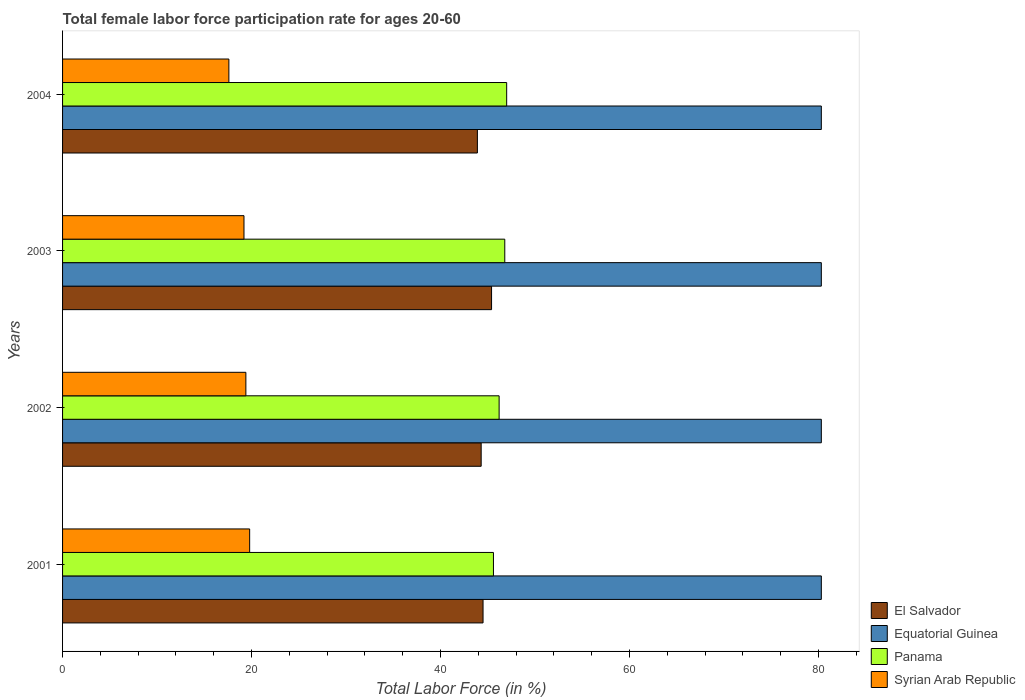How many different coloured bars are there?
Ensure brevity in your answer.  4. How many groups of bars are there?
Ensure brevity in your answer.  4. How many bars are there on the 1st tick from the top?
Ensure brevity in your answer.  4. In how many cases, is the number of bars for a given year not equal to the number of legend labels?
Make the answer very short. 0. What is the female labor force participation rate in Syrian Arab Republic in 2001?
Your answer should be very brief. 19.8. Across all years, what is the maximum female labor force participation rate in Syrian Arab Republic?
Your answer should be compact. 19.8. Across all years, what is the minimum female labor force participation rate in Panama?
Ensure brevity in your answer.  45.6. What is the total female labor force participation rate in Panama in the graph?
Your answer should be compact. 185.6. What is the difference between the female labor force participation rate in Syrian Arab Republic in 2004 and the female labor force participation rate in Equatorial Guinea in 2001?
Your answer should be very brief. -62.7. In the year 2001, what is the difference between the female labor force participation rate in El Salvador and female labor force participation rate in Panama?
Ensure brevity in your answer.  -1.1. In how many years, is the female labor force participation rate in Syrian Arab Republic greater than 20 %?
Provide a short and direct response. 0. What is the ratio of the female labor force participation rate in Equatorial Guinea in 2001 to that in 2004?
Keep it short and to the point. 1. What is the difference between the highest and the second highest female labor force participation rate in El Salvador?
Provide a short and direct response. 0.9. What is the difference between the highest and the lowest female labor force participation rate in Syrian Arab Republic?
Make the answer very short. 2.2. What does the 2nd bar from the top in 2002 represents?
Your answer should be very brief. Panama. What does the 1st bar from the bottom in 2004 represents?
Your response must be concise. El Salvador. Is it the case that in every year, the sum of the female labor force participation rate in El Salvador and female labor force participation rate in Panama is greater than the female labor force participation rate in Syrian Arab Republic?
Make the answer very short. Yes. How many bars are there?
Offer a terse response. 16. Are the values on the major ticks of X-axis written in scientific E-notation?
Offer a terse response. No. Does the graph contain any zero values?
Provide a short and direct response. No. Where does the legend appear in the graph?
Ensure brevity in your answer.  Bottom right. How many legend labels are there?
Your answer should be compact. 4. How are the legend labels stacked?
Provide a succinct answer. Vertical. What is the title of the graph?
Provide a short and direct response. Total female labor force participation rate for ages 20-60. Does "Guinea" appear as one of the legend labels in the graph?
Your answer should be compact. No. What is the Total Labor Force (in %) of El Salvador in 2001?
Your response must be concise. 44.5. What is the Total Labor Force (in %) of Equatorial Guinea in 2001?
Your answer should be compact. 80.3. What is the Total Labor Force (in %) of Panama in 2001?
Provide a succinct answer. 45.6. What is the Total Labor Force (in %) in Syrian Arab Republic in 2001?
Offer a very short reply. 19.8. What is the Total Labor Force (in %) in El Salvador in 2002?
Your answer should be compact. 44.3. What is the Total Labor Force (in %) of Equatorial Guinea in 2002?
Give a very brief answer. 80.3. What is the Total Labor Force (in %) of Panama in 2002?
Give a very brief answer. 46.2. What is the Total Labor Force (in %) in Syrian Arab Republic in 2002?
Your answer should be compact. 19.4. What is the Total Labor Force (in %) in El Salvador in 2003?
Offer a very short reply. 45.4. What is the Total Labor Force (in %) in Equatorial Guinea in 2003?
Offer a very short reply. 80.3. What is the Total Labor Force (in %) of Panama in 2003?
Your answer should be very brief. 46.8. What is the Total Labor Force (in %) of Syrian Arab Republic in 2003?
Give a very brief answer. 19.2. What is the Total Labor Force (in %) in El Salvador in 2004?
Your response must be concise. 43.9. What is the Total Labor Force (in %) in Equatorial Guinea in 2004?
Your answer should be very brief. 80.3. What is the Total Labor Force (in %) in Syrian Arab Republic in 2004?
Give a very brief answer. 17.6. Across all years, what is the maximum Total Labor Force (in %) of El Salvador?
Make the answer very short. 45.4. Across all years, what is the maximum Total Labor Force (in %) in Equatorial Guinea?
Provide a succinct answer. 80.3. Across all years, what is the maximum Total Labor Force (in %) in Panama?
Offer a very short reply. 47. Across all years, what is the maximum Total Labor Force (in %) in Syrian Arab Republic?
Provide a succinct answer. 19.8. Across all years, what is the minimum Total Labor Force (in %) of El Salvador?
Ensure brevity in your answer.  43.9. Across all years, what is the minimum Total Labor Force (in %) in Equatorial Guinea?
Offer a very short reply. 80.3. Across all years, what is the minimum Total Labor Force (in %) of Panama?
Ensure brevity in your answer.  45.6. Across all years, what is the minimum Total Labor Force (in %) in Syrian Arab Republic?
Give a very brief answer. 17.6. What is the total Total Labor Force (in %) in El Salvador in the graph?
Provide a short and direct response. 178.1. What is the total Total Labor Force (in %) of Equatorial Guinea in the graph?
Your response must be concise. 321.2. What is the total Total Labor Force (in %) of Panama in the graph?
Give a very brief answer. 185.6. What is the total Total Labor Force (in %) in Syrian Arab Republic in the graph?
Keep it short and to the point. 76. What is the difference between the Total Labor Force (in %) in Equatorial Guinea in 2001 and that in 2002?
Your answer should be very brief. 0. What is the difference between the Total Labor Force (in %) in Syrian Arab Republic in 2001 and that in 2003?
Provide a succinct answer. 0.6. What is the difference between the Total Labor Force (in %) of Syrian Arab Republic in 2001 and that in 2004?
Your response must be concise. 2.2. What is the difference between the Total Labor Force (in %) of Panama in 2002 and that in 2004?
Your answer should be compact. -0.8. What is the difference between the Total Labor Force (in %) in El Salvador in 2003 and that in 2004?
Keep it short and to the point. 1.5. What is the difference between the Total Labor Force (in %) in Equatorial Guinea in 2003 and that in 2004?
Your response must be concise. 0. What is the difference between the Total Labor Force (in %) in Panama in 2003 and that in 2004?
Offer a terse response. -0.2. What is the difference between the Total Labor Force (in %) in El Salvador in 2001 and the Total Labor Force (in %) in Equatorial Guinea in 2002?
Keep it short and to the point. -35.8. What is the difference between the Total Labor Force (in %) of El Salvador in 2001 and the Total Labor Force (in %) of Panama in 2002?
Offer a terse response. -1.7. What is the difference between the Total Labor Force (in %) in El Salvador in 2001 and the Total Labor Force (in %) in Syrian Arab Republic in 2002?
Keep it short and to the point. 25.1. What is the difference between the Total Labor Force (in %) in Equatorial Guinea in 2001 and the Total Labor Force (in %) in Panama in 2002?
Ensure brevity in your answer.  34.1. What is the difference between the Total Labor Force (in %) of Equatorial Guinea in 2001 and the Total Labor Force (in %) of Syrian Arab Republic in 2002?
Offer a terse response. 60.9. What is the difference between the Total Labor Force (in %) in Panama in 2001 and the Total Labor Force (in %) in Syrian Arab Republic in 2002?
Keep it short and to the point. 26.2. What is the difference between the Total Labor Force (in %) of El Salvador in 2001 and the Total Labor Force (in %) of Equatorial Guinea in 2003?
Offer a terse response. -35.8. What is the difference between the Total Labor Force (in %) of El Salvador in 2001 and the Total Labor Force (in %) of Syrian Arab Republic in 2003?
Ensure brevity in your answer.  25.3. What is the difference between the Total Labor Force (in %) in Equatorial Guinea in 2001 and the Total Labor Force (in %) in Panama in 2003?
Make the answer very short. 33.5. What is the difference between the Total Labor Force (in %) of Equatorial Guinea in 2001 and the Total Labor Force (in %) of Syrian Arab Republic in 2003?
Give a very brief answer. 61.1. What is the difference between the Total Labor Force (in %) in Panama in 2001 and the Total Labor Force (in %) in Syrian Arab Republic in 2003?
Provide a succinct answer. 26.4. What is the difference between the Total Labor Force (in %) in El Salvador in 2001 and the Total Labor Force (in %) in Equatorial Guinea in 2004?
Offer a very short reply. -35.8. What is the difference between the Total Labor Force (in %) in El Salvador in 2001 and the Total Labor Force (in %) in Syrian Arab Republic in 2004?
Ensure brevity in your answer.  26.9. What is the difference between the Total Labor Force (in %) in Equatorial Guinea in 2001 and the Total Labor Force (in %) in Panama in 2004?
Keep it short and to the point. 33.3. What is the difference between the Total Labor Force (in %) of Equatorial Guinea in 2001 and the Total Labor Force (in %) of Syrian Arab Republic in 2004?
Keep it short and to the point. 62.7. What is the difference between the Total Labor Force (in %) in El Salvador in 2002 and the Total Labor Force (in %) in Equatorial Guinea in 2003?
Give a very brief answer. -36. What is the difference between the Total Labor Force (in %) of El Salvador in 2002 and the Total Labor Force (in %) of Panama in 2003?
Offer a terse response. -2.5. What is the difference between the Total Labor Force (in %) of El Salvador in 2002 and the Total Labor Force (in %) of Syrian Arab Republic in 2003?
Your answer should be compact. 25.1. What is the difference between the Total Labor Force (in %) of Equatorial Guinea in 2002 and the Total Labor Force (in %) of Panama in 2003?
Your answer should be compact. 33.5. What is the difference between the Total Labor Force (in %) in Equatorial Guinea in 2002 and the Total Labor Force (in %) in Syrian Arab Republic in 2003?
Offer a very short reply. 61.1. What is the difference between the Total Labor Force (in %) of Panama in 2002 and the Total Labor Force (in %) of Syrian Arab Republic in 2003?
Provide a succinct answer. 27. What is the difference between the Total Labor Force (in %) of El Salvador in 2002 and the Total Labor Force (in %) of Equatorial Guinea in 2004?
Provide a short and direct response. -36. What is the difference between the Total Labor Force (in %) in El Salvador in 2002 and the Total Labor Force (in %) in Panama in 2004?
Offer a very short reply. -2.7. What is the difference between the Total Labor Force (in %) in El Salvador in 2002 and the Total Labor Force (in %) in Syrian Arab Republic in 2004?
Give a very brief answer. 26.7. What is the difference between the Total Labor Force (in %) of Equatorial Guinea in 2002 and the Total Labor Force (in %) of Panama in 2004?
Provide a succinct answer. 33.3. What is the difference between the Total Labor Force (in %) of Equatorial Guinea in 2002 and the Total Labor Force (in %) of Syrian Arab Republic in 2004?
Provide a short and direct response. 62.7. What is the difference between the Total Labor Force (in %) in Panama in 2002 and the Total Labor Force (in %) in Syrian Arab Republic in 2004?
Ensure brevity in your answer.  28.6. What is the difference between the Total Labor Force (in %) of El Salvador in 2003 and the Total Labor Force (in %) of Equatorial Guinea in 2004?
Your response must be concise. -34.9. What is the difference between the Total Labor Force (in %) in El Salvador in 2003 and the Total Labor Force (in %) in Panama in 2004?
Provide a short and direct response. -1.6. What is the difference between the Total Labor Force (in %) in El Salvador in 2003 and the Total Labor Force (in %) in Syrian Arab Republic in 2004?
Your answer should be very brief. 27.8. What is the difference between the Total Labor Force (in %) in Equatorial Guinea in 2003 and the Total Labor Force (in %) in Panama in 2004?
Offer a very short reply. 33.3. What is the difference between the Total Labor Force (in %) of Equatorial Guinea in 2003 and the Total Labor Force (in %) of Syrian Arab Republic in 2004?
Provide a succinct answer. 62.7. What is the difference between the Total Labor Force (in %) in Panama in 2003 and the Total Labor Force (in %) in Syrian Arab Republic in 2004?
Offer a very short reply. 29.2. What is the average Total Labor Force (in %) of El Salvador per year?
Offer a terse response. 44.52. What is the average Total Labor Force (in %) of Equatorial Guinea per year?
Make the answer very short. 80.3. What is the average Total Labor Force (in %) of Panama per year?
Provide a succinct answer. 46.4. What is the average Total Labor Force (in %) in Syrian Arab Republic per year?
Offer a very short reply. 19. In the year 2001, what is the difference between the Total Labor Force (in %) of El Salvador and Total Labor Force (in %) of Equatorial Guinea?
Keep it short and to the point. -35.8. In the year 2001, what is the difference between the Total Labor Force (in %) of El Salvador and Total Labor Force (in %) of Syrian Arab Republic?
Your response must be concise. 24.7. In the year 2001, what is the difference between the Total Labor Force (in %) in Equatorial Guinea and Total Labor Force (in %) in Panama?
Your answer should be very brief. 34.7. In the year 2001, what is the difference between the Total Labor Force (in %) in Equatorial Guinea and Total Labor Force (in %) in Syrian Arab Republic?
Your answer should be very brief. 60.5. In the year 2001, what is the difference between the Total Labor Force (in %) in Panama and Total Labor Force (in %) in Syrian Arab Republic?
Offer a very short reply. 25.8. In the year 2002, what is the difference between the Total Labor Force (in %) of El Salvador and Total Labor Force (in %) of Equatorial Guinea?
Give a very brief answer. -36. In the year 2002, what is the difference between the Total Labor Force (in %) in El Salvador and Total Labor Force (in %) in Panama?
Offer a very short reply. -1.9. In the year 2002, what is the difference between the Total Labor Force (in %) of El Salvador and Total Labor Force (in %) of Syrian Arab Republic?
Ensure brevity in your answer.  24.9. In the year 2002, what is the difference between the Total Labor Force (in %) of Equatorial Guinea and Total Labor Force (in %) of Panama?
Provide a succinct answer. 34.1. In the year 2002, what is the difference between the Total Labor Force (in %) of Equatorial Guinea and Total Labor Force (in %) of Syrian Arab Republic?
Your answer should be very brief. 60.9. In the year 2002, what is the difference between the Total Labor Force (in %) of Panama and Total Labor Force (in %) of Syrian Arab Republic?
Ensure brevity in your answer.  26.8. In the year 2003, what is the difference between the Total Labor Force (in %) of El Salvador and Total Labor Force (in %) of Equatorial Guinea?
Keep it short and to the point. -34.9. In the year 2003, what is the difference between the Total Labor Force (in %) of El Salvador and Total Labor Force (in %) of Syrian Arab Republic?
Offer a terse response. 26.2. In the year 2003, what is the difference between the Total Labor Force (in %) of Equatorial Guinea and Total Labor Force (in %) of Panama?
Your response must be concise. 33.5. In the year 2003, what is the difference between the Total Labor Force (in %) in Equatorial Guinea and Total Labor Force (in %) in Syrian Arab Republic?
Provide a short and direct response. 61.1. In the year 2003, what is the difference between the Total Labor Force (in %) in Panama and Total Labor Force (in %) in Syrian Arab Republic?
Your response must be concise. 27.6. In the year 2004, what is the difference between the Total Labor Force (in %) of El Salvador and Total Labor Force (in %) of Equatorial Guinea?
Make the answer very short. -36.4. In the year 2004, what is the difference between the Total Labor Force (in %) in El Salvador and Total Labor Force (in %) in Panama?
Offer a very short reply. -3.1. In the year 2004, what is the difference between the Total Labor Force (in %) in El Salvador and Total Labor Force (in %) in Syrian Arab Republic?
Offer a terse response. 26.3. In the year 2004, what is the difference between the Total Labor Force (in %) of Equatorial Guinea and Total Labor Force (in %) of Panama?
Your answer should be very brief. 33.3. In the year 2004, what is the difference between the Total Labor Force (in %) of Equatorial Guinea and Total Labor Force (in %) of Syrian Arab Republic?
Ensure brevity in your answer.  62.7. In the year 2004, what is the difference between the Total Labor Force (in %) in Panama and Total Labor Force (in %) in Syrian Arab Republic?
Provide a short and direct response. 29.4. What is the ratio of the Total Labor Force (in %) in El Salvador in 2001 to that in 2002?
Provide a succinct answer. 1. What is the ratio of the Total Labor Force (in %) of Panama in 2001 to that in 2002?
Provide a short and direct response. 0.99. What is the ratio of the Total Labor Force (in %) of Syrian Arab Republic in 2001 to that in 2002?
Offer a very short reply. 1.02. What is the ratio of the Total Labor Force (in %) of El Salvador in 2001 to that in 2003?
Give a very brief answer. 0.98. What is the ratio of the Total Labor Force (in %) of Panama in 2001 to that in 2003?
Your response must be concise. 0.97. What is the ratio of the Total Labor Force (in %) in Syrian Arab Republic in 2001 to that in 2003?
Offer a terse response. 1.03. What is the ratio of the Total Labor Force (in %) in El Salvador in 2001 to that in 2004?
Your response must be concise. 1.01. What is the ratio of the Total Labor Force (in %) of Panama in 2001 to that in 2004?
Your answer should be very brief. 0.97. What is the ratio of the Total Labor Force (in %) of El Salvador in 2002 to that in 2003?
Your response must be concise. 0.98. What is the ratio of the Total Labor Force (in %) of Equatorial Guinea in 2002 to that in 2003?
Your answer should be compact. 1. What is the ratio of the Total Labor Force (in %) of Panama in 2002 to that in 2003?
Provide a short and direct response. 0.99. What is the ratio of the Total Labor Force (in %) of Syrian Arab Republic in 2002 to that in 2003?
Your answer should be very brief. 1.01. What is the ratio of the Total Labor Force (in %) of El Salvador in 2002 to that in 2004?
Offer a very short reply. 1.01. What is the ratio of the Total Labor Force (in %) in Panama in 2002 to that in 2004?
Provide a short and direct response. 0.98. What is the ratio of the Total Labor Force (in %) of Syrian Arab Republic in 2002 to that in 2004?
Provide a short and direct response. 1.1. What is the ratio of the Total Labor Force (in %) in El Salvador in 2003 to that in 2004?
Keep it short and to the point. 1.03. What is the ratio of the Total Labor Force (in %) in Equatorial Guinea in 2003 to that in 2004?
Give a very brief answer. 1. What is the ratio of the Total Labor Force (in %) in Panama in 2003 to that in 2004?
Your response must be concise. 1. What is the difference between the highest and the second highest Total Labor Force (in %) of El Salvador?
Your answer should be compact. 0.9. What is the difference between the highest and the second highest Total Labor Force (in %) of Panama?
Give a very brief answer. 0.2. What is the difference between the highest and the lowest Total Labor Force (in %) in Panama?
Your answer should be very brief. 1.4. 